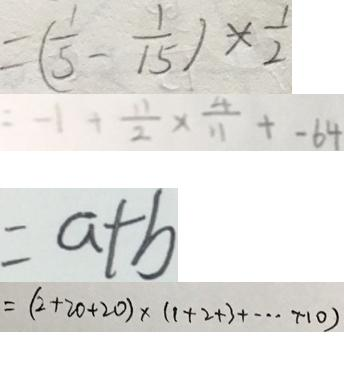Convert formula to latex. <formula><loc_0><loc_0><loc_500><loc_500>= ( \frac { 1 } { 5 } - \frac { 1 } { 1 5 } ) \times \frac { 1 } { 2 } 
 = - 1 + \frac { 1 1 } { 2 } \times \frac { 4 } { 1 1 } + - 6 4 
 = a + b 
 = ( 2 + 2 0 + 2 0 ) \times ( 1 + 2 + 3 + \cdots + 1 0 )</formula> 